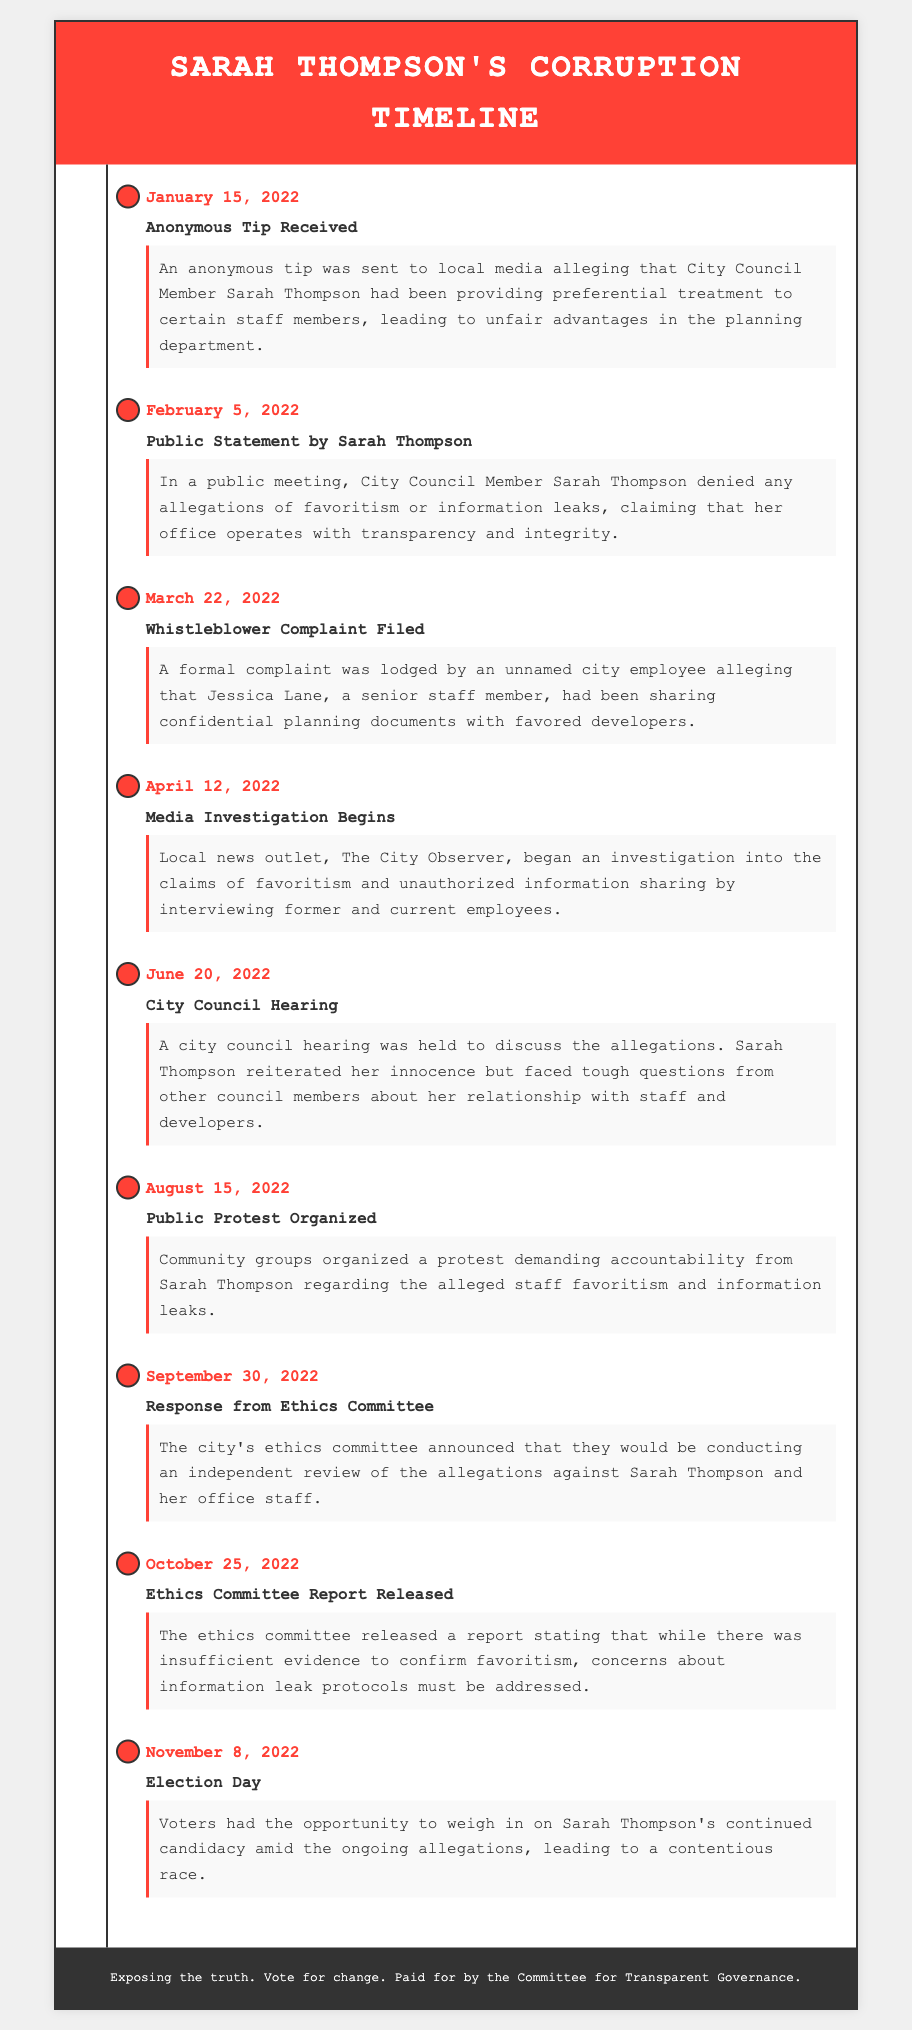What is the date of the anonymous tip received? The date when the anonymous tip alleging favoritism was sent is clearly stated in the document as January 15, 2022.
Answer: January 15, 2022 Who filed a complaint alleging information leaks? The complaint was filed by an unnamed city employee, as indicated in the document.
Answer: An unnamed city employee What was the title of the media outlet that began investigating? The document specifies that the local news outlet conducting the investigation was The City Observer.
Answer: The City Observer On which date did the ethics committee announce an independent review? The document states that the ethics committee's announcement occurred on September 30, 2022.
Answer: September 30, 2022 What was one major outcome of the ethics committee report released? The report highlighted concerns about information leak protocols needing to be addressed.
Answer: Concerns about information leak protocols What relationship did Sarah Thompson have with Jessica Lane according to the allegations? Jessica Lane is mentioned as a senior staff member connected to the allegations of favoritism and information leaks.
Answer: Senior staff member How long after the anonymous tip was the whistleblower complaint filed? The whistleblower complaint was filed on March 22, 2022, which is 2 months after the anonymous tip.
Answer: 2 months Which community event was organized to demand accountability? The document describes a public protest organized on August 15, 2022, as a response to the allegations.
Answer: Public protest When did Sarah Thompson deny any allegations of favoritism? The denial of allegations occurred in a public statement on February 5, 2022.
Answer: February 5, 2022 